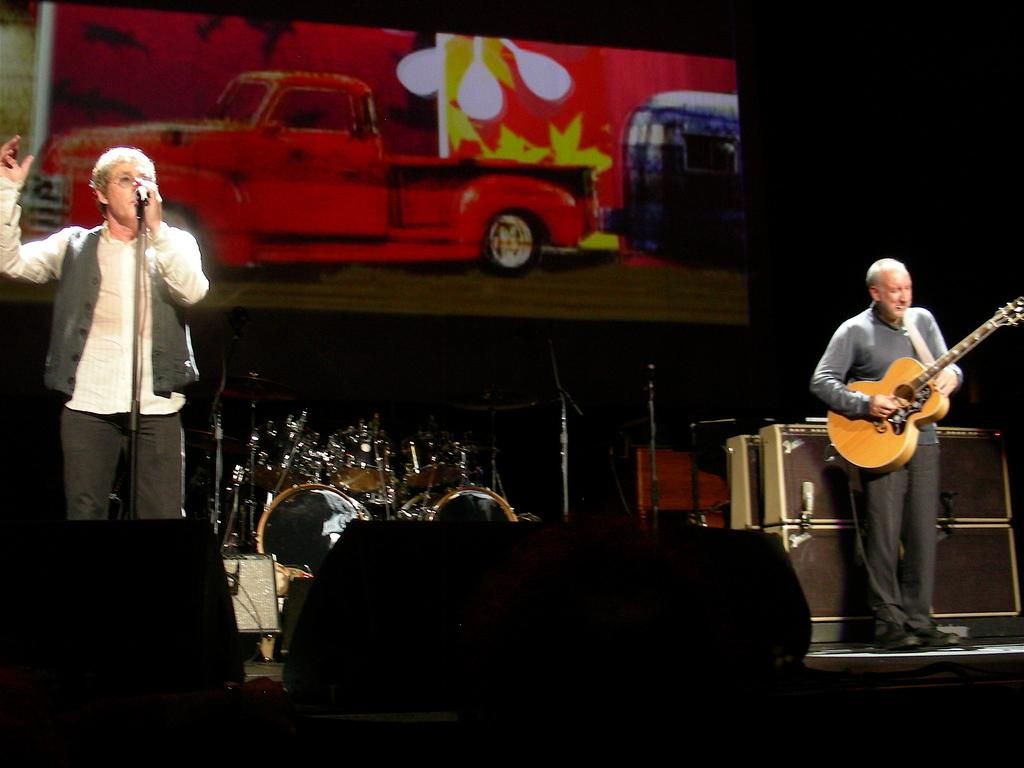How many people are in the image? There are two men in the image. What are the men doing in the image? One man is playing a guitar, and the other man is singing into a microphone. Where are the men located in the image? The men are standing on a stage. What type of flag is being waved by the man playing the guitar in the image? There is no flag present in the image; the man playing the guitar is focused on playing his instrument. 